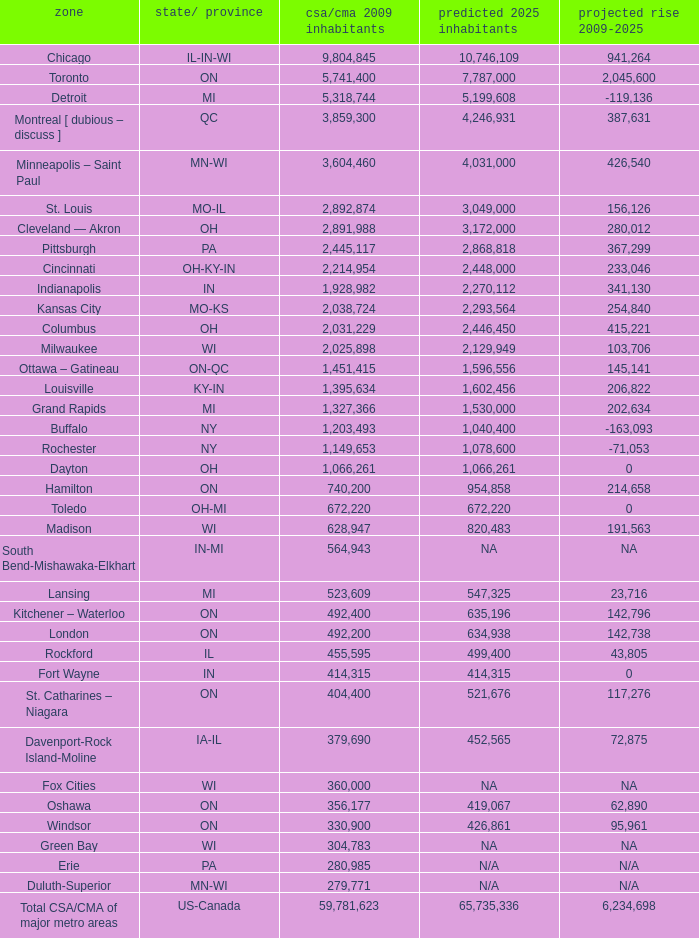What's the CSA/CMA Population in IA-IL? 379690.0. 